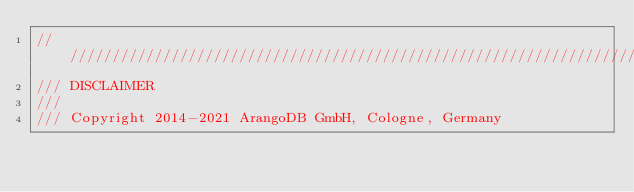Convert code to text. <code><loc_0><loc_0><loc_500><loc_500><_C++_>////////////////////////////////////////////////////////////////////////////////
/// DISCLAIMER
///
/// Copyright 2014-2021 ArangoDB GmbH, Cologne, Germany</code> 